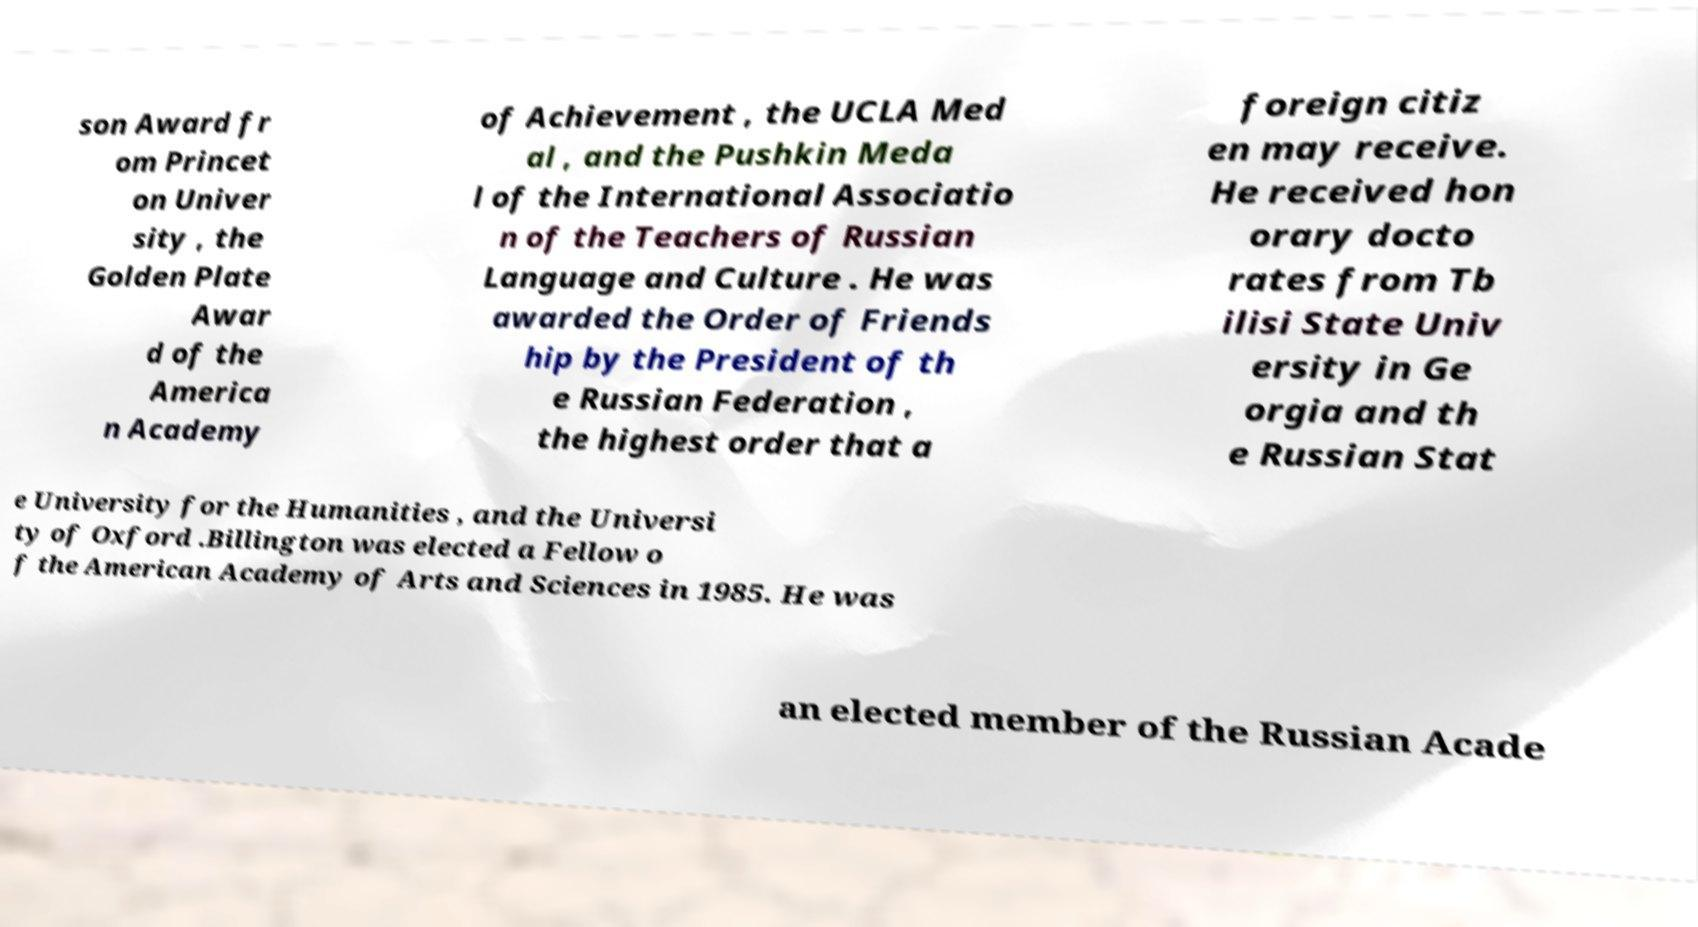Can you accurately transcribe the text from the provided image for me? son Award fr om Princet on Univer sity , the Golden Plate Awar d of the America n Academy of Achievement , the UCLA Med al , and the Pushkin Meda l of the International Associatio n of the Teachers of Russian Language and Culture . He was awarded the Order of Friends hip by the President of th e Russian Federation , the highest order that a foreign citiz en may receive. He received hon orary docto rates from Tb ilisi State Univ ersity in Ge orgia and th e Russian Stat e University for the Humanities , and the Universi ty of Oxford .Billington was elected a Fellow o f the American Academy of Arts and Sciences in 1985. He was an elected member of the Russian Acade 